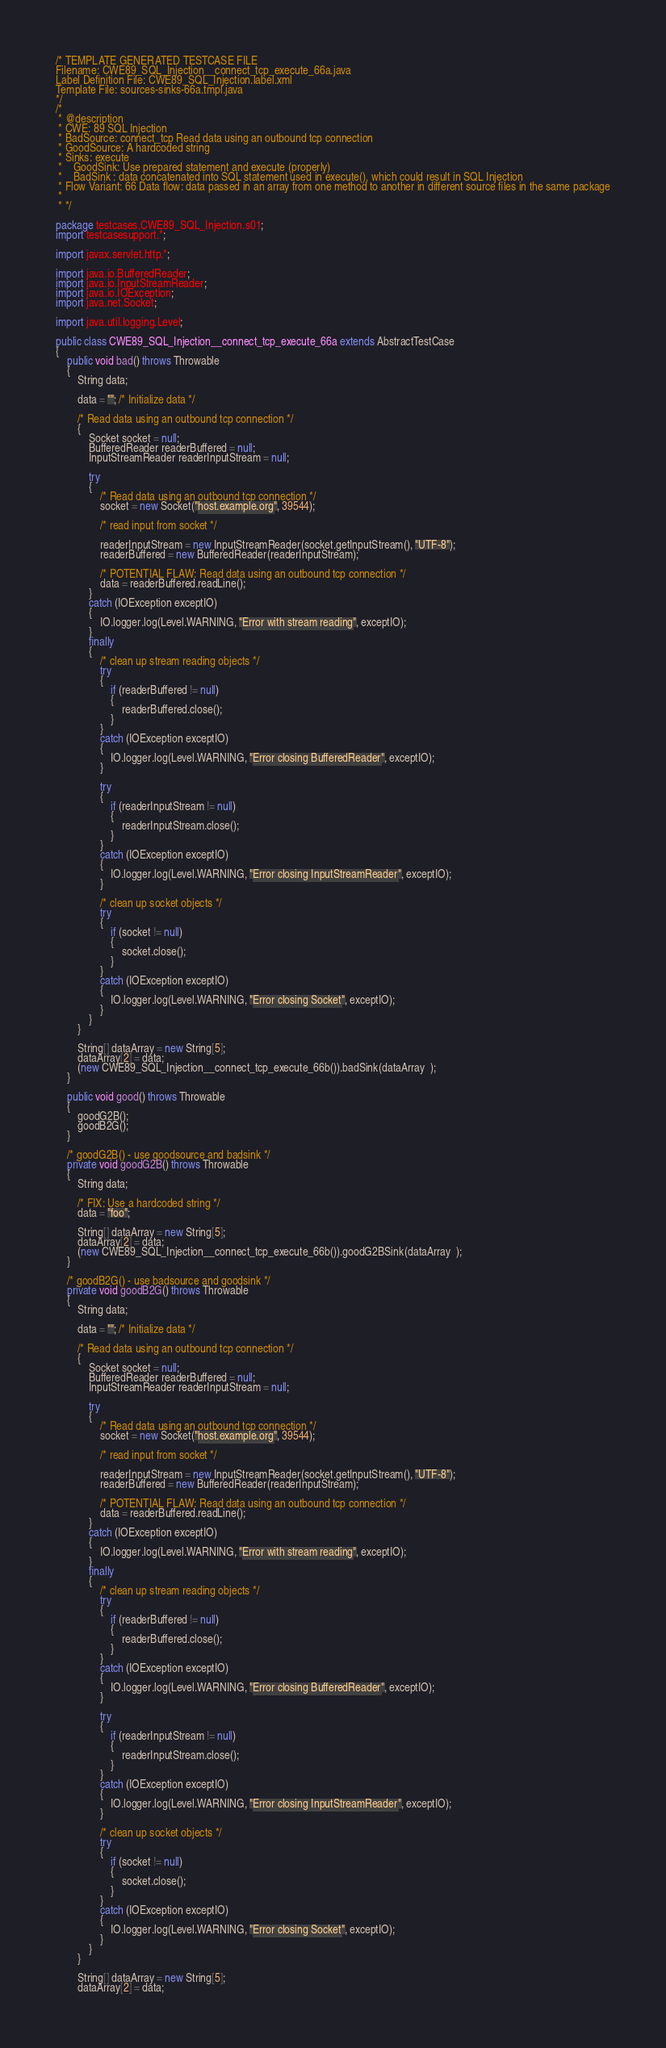Convert code to text. <code><loc_0><loc_0><loc_500><loc_500><_Java_>/* TEMPLATE GENERATED TESTCASE FILE
Filename: CWE89_SQL_Injection__connect_tcp_execute_66a.java
Label Definition File: CWE89_SQL_Injection.label.xml
Template File: sources-sinks-66a.tmpl.java
*/
/*
 * @description
 * CWE: 89 SQL Injection
 * BadSource: connect_tcp Read data using an outbound tcp connection
 * GoodSource: A hardcoded string
 * Sinks: execute
 *    GoodSink: Use prepared statement and execute (properly)
 *    BadSink : data concatenated into SQL statement used in execute(), which could result in SQL Injection
 * Flow Variant: 66 Data flow: data passed in an array from one method to another in different source files in the same package
 *
 * */

package testcases.CWE89_SQL_Injection.s01;
import testcasesupport.*;

import javax.servlet.http.*;

import java.io.BufferedReader;
import java.io.InputStreamReader;
import java.io.IOException;
import java.net.Socket;

import java.util.logging.Level;

public class CWE89_SQL_Injection__connect_tcp_execute_66a extends AbstractTestCase
{
    public void bad() throws Throwable
    {
        String data;

        data = ""; /* Initialize data */

        /* Read data using an outbound tcp connection */
        {
            Socket socket = null;
            BufferedReader readerBuffered = null;
            InputStreamReader readerInputStream = null;

            try
            {
                /* Read data using an outbound tcp connection */
                socket = new Socket("host.example.org", 39544);

                /* read input from socket */

                readerInputStream = new InputStreamReader(socket.getInputStream(), "UTF-8");
                readerBuffered = new BufferedReader(readerInputStream);

                /* POTENTIAL FLAW: Read data using an outbound tcp connection */
                data = readerBuffered.readLine();
            }
            catch (IOException exceptIO)
            {
                IO.logger.log(Level.WARNING, "Error with stream reading", exceptIO);
            }
            finally
            {
                /* clean up stream reading objects */
                try
                {
                    if (readerBuffered != null)
                    {
                        readerBuffered.close();
                    }
                }
                catch (IOException exceptIO)
                {
                    IO.logger.log(Level.WARNING, "Error closing BufferedReader", exceptIO);
                }

                try
                {
                    if (readerInputStream != null)
                    {
                        readerInputStream.close();
                    }
                }
                catch (IOException exceptIO)
                {
                    IO.logger.log(Level.WARNING, "Error closing InputStreamReader", exceptIO);
                }

                /* clean up socket objects */
                try
                {
                    if (socket != null)
                    {
                        socket.close();
                    }
                }
                catch (IOException exceptIO)
                {
                    IO.logger.log(Level.WARNING, "Error closing Socket", exceptIO);
                }
            }
        }

        String[] dataArray = new String[5];
        dataArray[2] = data;
        (new CWE89_SQL_Injection__connect_tcp_execute_66b()).badSink(dataArray  );
    }

    public void good() throws Throwable
    {
        goodG2B();
        goodB2G();
    }

    /* goodG2B() - use goodsource and badsink */
    private void goodG2B() throws Throwable
    {
        String data;

        /* FIX: Use a hardcoded string */
        data = "foo";

        String[] dataArray = new String[5];
        dataArray[2] = data;
        (new CWE89_SQL_Injection__connect_tcp_execute_66b()).goodG2BSink(dataArray  );
    }

    /* goodB2G() - use badsource and goodsink */
    private void goodB2G() throws Throwable
    {
        String data;

        data = ""; /* Initialize data */

        /* Read data using an outbound tcp connection */
        {
            Socket socket = null;
            BufferedReader readerBuffered = null;
            InputStreamReader readerInputStream = null;

            try
            {
                /* Read data using an outbound tcp connection */
                socket = new Socket("host.example.org", 39544);

                /* read input from socket */

                readerInputStream = new InputStreamReader(socket.getInputStream(), "UTF-8");
                readerBuffered = new BufferedReader(readerInputStream);

                /* POTENTIAL FLAW: Read data using an outbound tcp connection */
                data = readerBuffered.readLine();
            }
            catch (IOException exceptIO)
            {
                IO.logger.log(Level.WARNING, "Error with stream reading", exceptIO);
            }
            finally
            {
                /* clean up stream reading objects */
                try
                {
                    if (readerBuffered != null)
                    {
                        readerBuffered.close();
                    }
                }
                catch (IOException exceptIO)
                {
                    IO.logger.log(Level.WARNING, "Error closing BufferedReader", exceptIO);
                }

                try
                {
                    if (readerInputStream != null)
                    {
                        readerInputStream.close();
                    }
                }
                catch (IOException exceptIO)
                {
                    IO.logger.log(Level.WARNING, "Error closing InputStreamReader", exceptIO);
                }

                /* clean up socket objects */
                try
                {
                    if (socket != null)
                    {
                        socket.close();
                    }
                }
                catch (IOException exceptIO)
                {
                    IO.logger.log(Level.WARNING, "Error closing Socket", exceptIO);
                }
            }
        }

        String[] dataArray = new String[5];
        dataArray[2] = data;</code> 